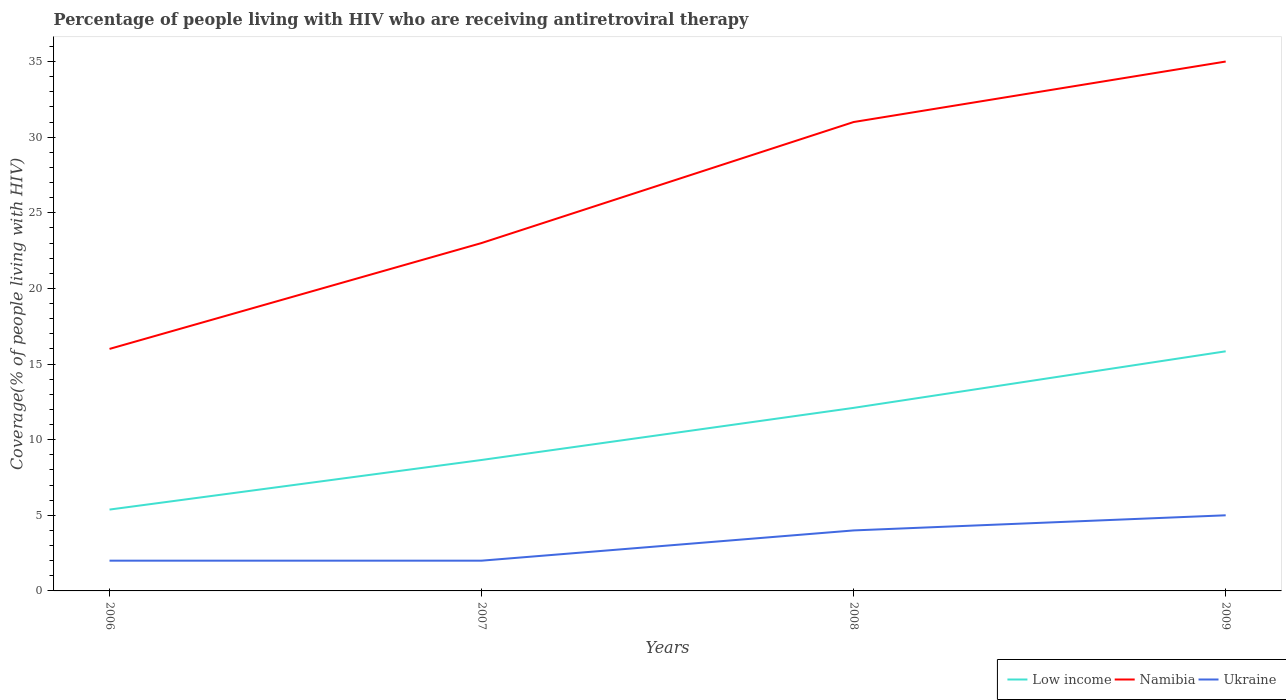How many different coloured lines are there?
Your answer should be very brief. 3. Across all years, what is the maximum percentage of the HIV infected people who are receiving antiretroviral therapy in Namibia?
Give a very brief answer. 16. In which year was the percentage of the HIV infected people who are receiving antiretroviral therapy in Low income maximum?
Ensure brevity in your answer.  2006. What is the total percentage of the HIV infected people who are receiving antiretroviral therapy in Namibia in the graph?
Ensure brevity in your answer.  -8. What is the difference between the highest and the second highest percentage of the HIV infected people who are receiving antiretroviral therapy in Low income?
Give a very brief answer. 10.46. Is the percentage of the HIV infected people who are receiving antiretroviral therapy in Namibia strictly greater than the percentage of the HIV infected people who are receiving antiretroviral therapy in Low income over the years?
Keep it short and to the point. No. Are the values on the major ticks of Y-axis written in scientific E-notation?
Your answer should be compact. No. Does the graph contain any zero values?
Your answer should be very brief. No. Does the graph contain grids?
Make the answer very short. No. Where does the legend appear in the graph?
Keep it short and to the point. Bottom right. What is the title of the graph?
Offer a very short reply. Percentage of people living with HIV who are receiving antiretroviral therapy. What is the label or title of the X-axis?
Give a very brief answer. Years. What is the label or title of the Y-axis?
Your response must be concise. Coverage(% of people living with HIV). What is the Coverage(% of people living with HIV) in Low income in 2006?
Provide a short and direct response. 5.38. What is the Coverage(% of people living with HIV) of Namibia in 2006?
Offer a very short reply. 16. What is the Coverage(% of people living with HIV) in Low income in 2007?
Your response must be concise. 8.66. What is the Coverage(% of people living with HIV) in Ukraine in 2007?
Your response must be concise. 2. What is the Coverage(% of people living with HIV) of Low income in 2008?
Provide a succinct answer. 12.1. What is the Coverage(% of people living with HIV) of Namibia in 2008?
Your answer should be very brief. 31. What is the Coverage(% of people living with HIV) of Low income in 2009?
Offer a terse response. 15.84. Across all years, what is the maximum Coverage(% of people living with HIV) in Low income?
Provide a succinct answer. 15.84. Across all years, what is the maximum Coverage(% of people living with HIV) of Namibia?
Ensure brevity in your answer.  35. Across all years, what is the maximum Coverage(% of people living with HIV) of Ukraine?
Make the answer very short. 5. Across all years, what is the minimum Coverage(% of people living with HIV) in Low income?
Provide a short and direct response. 5.38. Across all years, what is the minimum Coverage(% of people living with HIV) of Namibia?
Your response must be concise. 16. What is the total Coverage(% of people living with HIV) in Low income in the graph?
Offer a very short reply. 41.98. What is the total Coverage(% of people living with HIV) in Namibia in the graph?
Make the answer very short. 105. What is the difference between the Coverage(% of people living with HIV) of Low income in 2006 and that in 2007?
Provide a short and direct response. -3.28. What is the difference between the Coverage(% of people living with HIV) in Ukraine in 2006 and that in 2007?
Offer a very short reply. 0. What is the difference between the Coverage(% of people living with HIV) in Low income in 2006 and that in 2008?
Keep it short and to the point. -6.72. What is the difference between the Coverage(% of people living with HIV) in Ukraine in 2006 and that in 2008?
Your response must be concise. -2. What is the difference between the Coverage(% of people living with HIV) in Low income in 2006 and that in 2009?
Make the answer very short. -10.46. What is the difference between the Coverage(% of people living with HIV) in Namibia in 2006 and that in 2009?
Make the answer very short. -19. What is the difference between the Coverage(% of people living with HIV) in Ukraine in 2006 and that in 2009?
Your answer should be very brief. -3. What is the difference between the Coverage(% of people living with HIV) of Low income in 2007 and that in 2008?
Your answer should be very brief. -3.45. What is the difference between the Coverage(% of people living with HIV) in Namibia in 2007 and that in 2008?
Offer a very short reply. -8. What is the difference between the Coverage(% of people living with HIV) in Ukraine in 2007 and that in 2008?
Your answer should be very brief. -2. What is the difference between the Coverage(% of people living with HIV) in Low income in 2007 and that in 2009?
Provide a short and direct response. -7.18. What is the difference between the Coverage(% of people living with HIV) of Namibia in 2007 and that in 2009?
Keep it short and to the point. -12. What is the difference between the Coverage(% of people living with HIV) in Ukraine in 2007 and that in 2009?
Offer a terse response. -3. What is the difference between the Coverage(% of people living with HIV) of Low income in 2008 and that in 2009?
Offer a terse response. -3.74. What is the difference between the Coverage(% of people living with HIV) in Namibia in 2008 and that in 2009?
Provide a short and direct response. -4. What is the difference between the Coverage(% of people living with HIV) of Ukraine in 2008 and that in 2009?
Your response must be concise. -1. What is the difference between the Coverage(% of people living with HIV) of Low income in 2006 and the Coverage(% of people living with HIV) of Namibia in 2007?
Make the answer very short. -17.62. What is the difference between the Coverage(% of people living with HIV) of Low income in 2006 and the Coverage(% of people living with HIV) of Ukraine in 2007?
Your answer should be very brief. 3.38. What is the difference between the Coverage(% of people living with HIV) in Low income in 2006 and the Coverage(% of people living with HIV) in Namibia in 2008?
Give a very brief answer. -25.62. What is the difference between the Coverage(% of people living with HIV) in Low income in 2006 and the Coverage(% of people living with HIV) in Ukraine in 2008?
Offer a terse response. 1.38. What is the difference between the Coverage(% of people living with HIV) in Namibia in 2006 and the Coverage(% of people living with HIV) in Ukraine in 2008?
Provide a short and direct response. 12. What is the difference between the Coverage(% of people living with HIV) of Low income in 2006 and the Coverage(% of people living with HIV) of Namibia in 2009?
Your answer should be very brief. -29.62. What is the difference between the Coverage(% of people living with HIV) in Low income in 2006 and the Coverage(% of people living with HIV) in Ukraine in 2009?
Your answer should be very brief. 0.38. What is the difference between the Coverage(% of people living with HIV) of Namibia in 2006 and the Coverage(% of people living with HIV) of Ukraine in 2009?
Keep it short and to the point. 11. What is the difference between the Coverage(% of people living with HIV) of Low income in 2007 and the Coverage(% of people living with HIV) of Namibia in 2008?
Your response must be concise. -22.34. What is the difference between the Coverage(% of people living with HIV) of Low income in 2007 and the Coverage(% of people living with HIV) of Ukraine in 2008?
Ensure brevity in your answer.  4.66. What is the difference between the Coverage(% of people living with HIV) in Low income in 2007 and the Coverage(% of people living with HIV) in Namibia in 2009?
Your answer should be very brief. -26.34. What is the difference between the Coverage(% of people living with HIV) of Low income in 2007 and the Coverage(% of people living with HIV) of Ukraine in 2009?
Keep it short and to the point. 3.66. What is the difference between the Coverage(% of people living with HIV) in Low income in 2008 and the Coverage(% of people living with HIV) in Namibia in 2009?
Make the answer very short. -22.9. What is the difference between the Coverage(% of people living with HIV) of Low income in 2008 and the Coverage(% of people living with HIV) of Ukraine in 2009?
Your answer should be compact. 7.1. What is the difference between the Coverage(% of people living with HIV) in Namibia in 2008 and the Coverage(% of people living with HIV) in Ukraine in 2009?
Ensure brevity in your answer.  26. What is the average Coverage(% of people living with HIV) of Low income per year?
Your answer should be very brief. 10.5. What is the average Coverage(% of people living with HIV) of Namibia per year?
Provide a short and direct response. 26.25. In the year 2006, what is the difference between the Coverage(% of people living with HIV) of Low income and Coverage(% of people living with HIV) of Namibia?
Provide a succinct answer. -10.62. In the year 2006, what is the difference between the Coverage(% of people living with HIV) of Low income and Coverage(% of people living with HIV) of Ukraine?
Make the answer very short. 3.38. In the year 2006, what is the difference between the Coverage(% of people living with HIV) in Namibia and Coverage(% of people living with HIV) in Ukraine?
Give a very brief answer. 14. In the year 2007, what is the difference between the Coverage(% of people living with HIV) in Low income and Coverage(% of people living with HIV) in Namibia?
Keep it short and to the point. -14.34. In the year 2007, what is the difference between the Coverage(% of people living with HIV) in Low income and Coverage(% of people living with HIV) in Ukraine?
Offer a terse response. 6.66. In the year 2007, what is the difference between the Coverage(% of people living with HIV) in Namibia and Coverage(% of people living with HIV) in Ukraine?
Your answer should be very brief. 21. In the year 2008, what is the difference between the Coverage(% of people living with HIV) of Low income and Coverage(% of people living with HIV) of Namibia?
Provide a succinct answer. -18.9. In the year 2008, what is the difference between the Coverage(% of people living with HIV) in Low income and Coverage(% of people living with HIV) in Ukraine?
Provide a short and direct response. 8.1. In the year 2008, what is the difference between the Coverage(% of people living with HIV) in Namibia and Coverage(% of people living with HIV) in Ukraine?
Ensure brevity in your answer.  27. In the year 2009, what is the difference between the Coverage(% of people living with HIV) of Low income and Coverage(% of people living with HIV) of Namibia?
Your answer should be very brief. -19.16. In the year 2009, what is the difference between the Coverage(% of people living with HIV) in Low income and Coverage(% of people living with HIV) in Ukraine?
Your answer should be compact. 10.84. In the year 2009, what is the difference between the Coverage(% of people living with HIV) of Namibia and Coverage(% of people living with HIV) of Ukraine?
Offer a terse response. 30. What is the ratio of the Coverage(% of people living with HIV) of Low income in 2006 to that in 2007?
Provide a succinct answer. 0.62. What is the ratio of the Coverage(% of people living with HIV) in Namibia in 2006 to that in 2007?
Make the answer very short. 0.7. What is the ratio of the Coverage(% of people living with HIV) of Ukraine in 2006 to that in 2007?
Your answer should be compact. 1. What is the ratio of the Coverage(% of people living with HIV) of Low income in 2006 to that in 2008?
Your response must be concise. 0.44. What is the ratio of the Coverage(% of people living with HIV) of Namibia in 2006 to that in 2008?
Offer a very short reply. 0.52. What is the ratio of the Coverage(% of people living with HIV) in Ukraine in 2006 to that in 2008?
Keep it short and to the point. 0.5. What is the ratio of the Coverage(% of people living with HIV) of Low income in 2006 to that in 2009?
Offer a terse response. 0.34. What is the ratio of the Coverage(% of people living with HIV) in Namibia in 2006 to that in 2009?
Offer a terse response. 0.46. What is the ratio of the Coverage(% of people living with HIV) in Low income in 2007 to that in 2008?
Provide a short and direct response. 0.72. What is the ratio of the Coverage(% of people living with HIV) of Namibia in 2007 to that in 2008?
Your answer should be very brief. 0.74. What is the ratio of the Coverage(% of people living with HIV) of Ukraine in 2007 to that in 2008?
Provide a short and direct response. 0.5. What is the ratio of the Coverage(% of people living with HIV) in Low income in 2007 to that in 2009?
Ensure brevity in your answer.  0.55. What is the ratio of the Coverage(% of people living with HIV) in Namibia in 2007 to that in 2009?
Keep it short and to the point. 0.66. What is the ratio of the Coverage(% of people living with HIV) of Low income in 2008 to that in 2009?
Your answer should be compact. 0.76. What is the ratio of the Coverage(% of people living with HIV) of Namibia in 2008 to that in 2009?
Give a very brief answer. 0.89. What is the ratio of the Coverage(% of people living with HIV) in Ukraine in 2008 to that in 2009?
Your response must be concise. 0.8. What is the difference between the highest and the second highest Coverage(% of people living with HIV) in Low income?
Provide a succinct answer. 3.74. What is the difference between the highest and the second highest Coverage(% of people living with HIV) in Namibia?
Your response must be concise. 4. What is the difference between the highest and the lowest Coverage(% of people living with HIV) in Low income?
Ensure brevity in your answer.  10.46. What is the difference between the highest and the lowest Coverage(% of people living with HIV) in Namibia?
Provide a succinct answer. 19. 